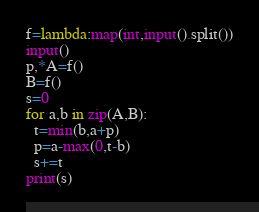Convert code to text. <code><loc_0><loc_0><loc_500><loc_500><_Python_>f=lambda:map(int,input().split())
input()
p,*A=f()
B=f()
s=0
for a,b in zip(A,B):
  t=min(b,a+p)
  p=a-max(0,t-b)
  s+=t
print(s)</code> 